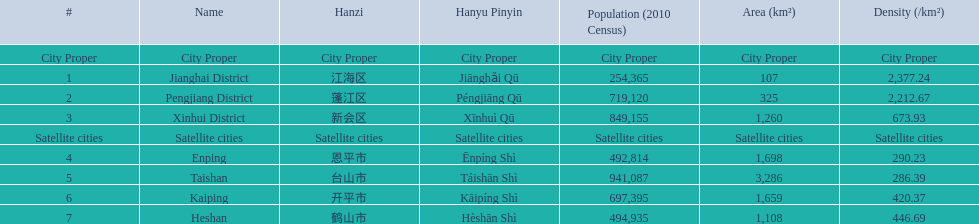Which zone has the greatest population? Taishan. 